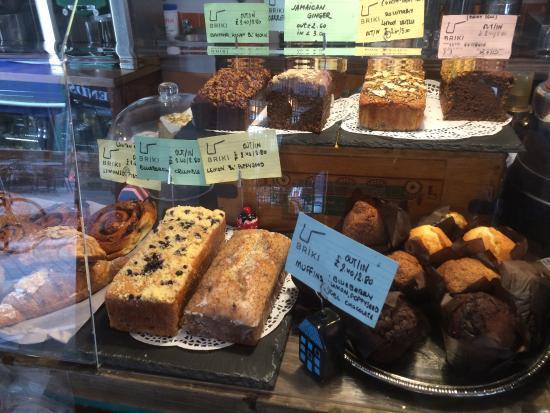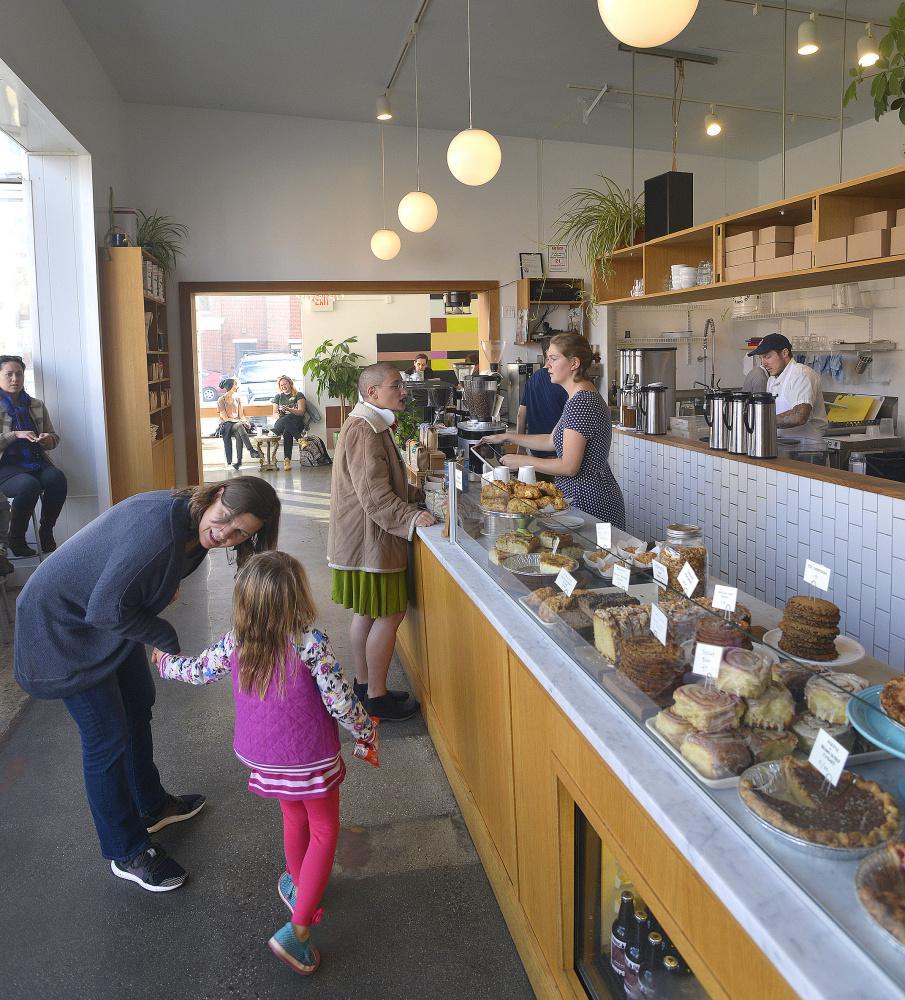The first image is the image on the left, the second image is the image on the right. Analyze the images presented: Is the assertion "In the image to the right, you can see the customers." valid? Answer yes or no. Yes. The first image is the image on the left, the second image is the image on the right. Analyze the images presented: Is the assertion "An image shows two people standing upright a distance apart in front of a counter with a light wood front and a top filled with containers of baked treats marked with cards." valid? Answer yes or no. Yes. 